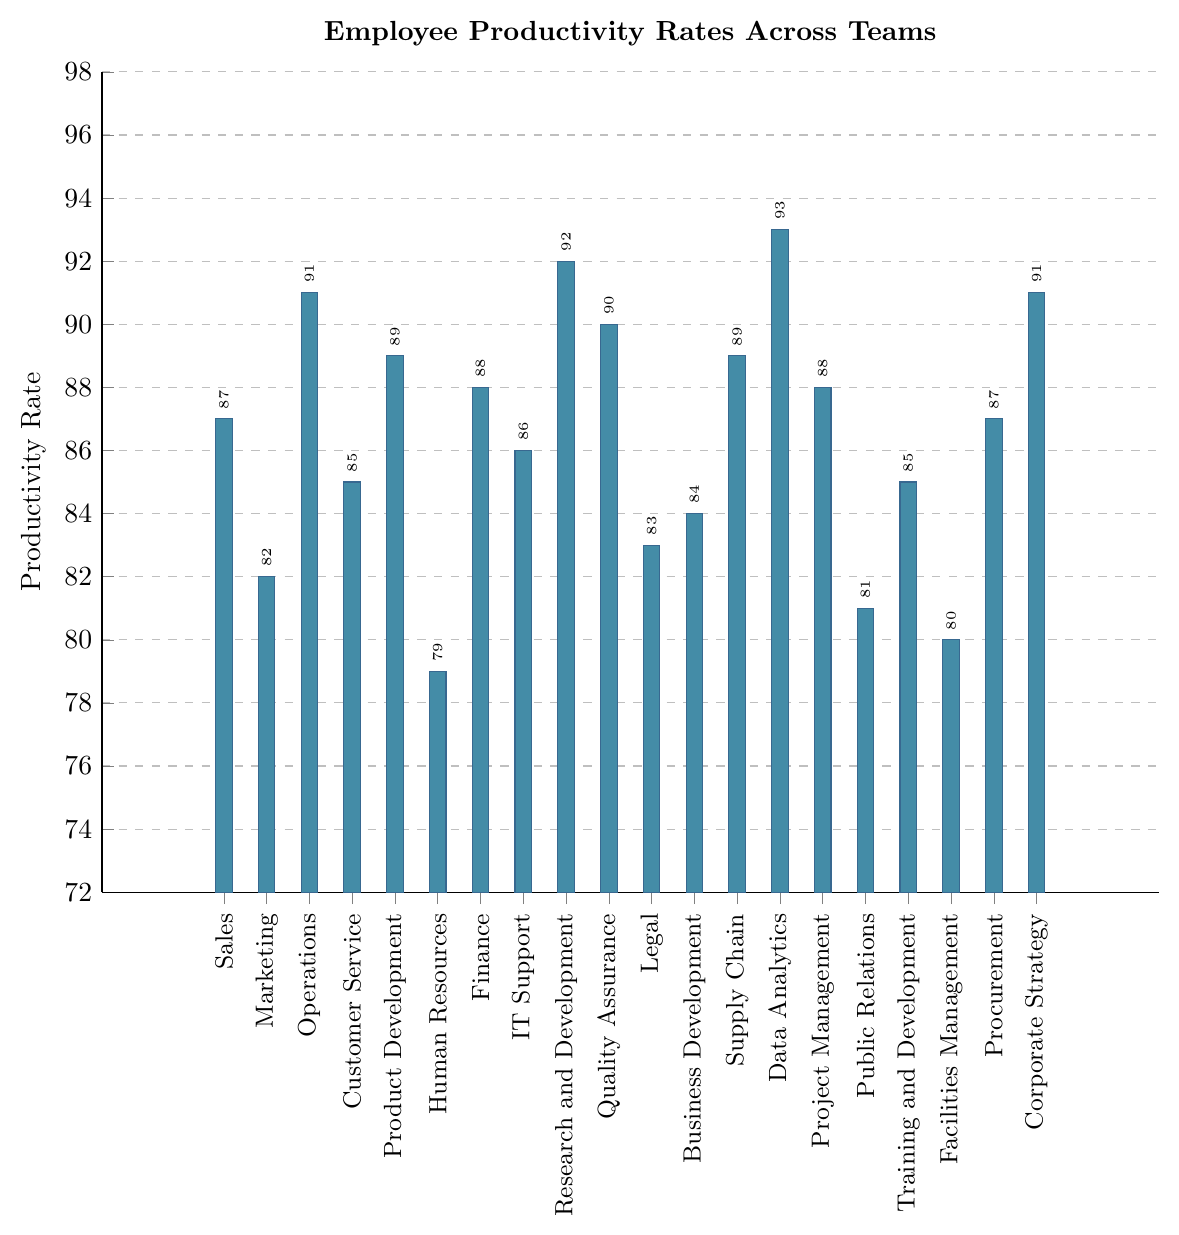Which team has the highest productivity rate? The team with the highest bar in the plot represents the highest productivity rate. The height of the 'Data Analytics' bar is the highest, indicating it has the highest rate.
Answer: Data Analytics Which team has the lowest productivity rate? The team with the lowest bar in the plot represents the lowest productivity rate. The height of the 'Human Resources' bar is the lowest, indicating it has the lowest rate.
Answer: Human Resources How many teams have productivity rates above 90? Identify the bars that surpass the 90 mark on the y-axis. There are four bars higher than 90, specifically those for 'Operations', 'Research and Development', 'Quality Assurance', and 'Data Analytics'.
Answer: 4 What is the difference in productivity rates between the Operations team and the Finance team? Subtract the productivity rate of the Finance team (88) from the productivity rate of the Operations team (91).
Answer: 3 What is the average productivity rate of the teams with productivity rates above 90? First, identify the teams with rates above 90: Operations (91), Research and Development (92), Quality Assurance (90), and Data Analytics (93). The average is calculated as (91 + 92 + 90 + 93) / 4 = 366 / 4.
Answer: 91.5 Which teams have productivity rates exactly equal to 87? Identify the teams whose bars reach up to the 87 mark on the y-axis. The teams are 'Sales' and 'Procurement'.
Answer: Sales, Procurement How does the productivity rate of the Marketing team compare to that of the Legal team? Compare the heights of the bars for 'Marketing' and 'Legal'. The bar for 'Marketing' is lower than that for 'Legal'.
Answer: Marketing is lower What is the range of productivity rates across all teams? Identify the minimum (Human Resources, 79) and maximum (Data Analytics, 93) productivity rates. The range is calculated by subtracting the minimum from the maximum (93 - 79).
Answer: 14 Which teams have productivity rates above the median productivity rate? First, list all productivity rates: 79, 80, 81, 82, 83, 84, 85, 85, 86, 87, 87, 88, 88, 89, 89, 90, 91, 91, 92, 93. The median is the average of the 10th and 11th values (87 + 87) / 2 = 87. Identify teams above this median: Operations, Finance, Research and Development, Quality Assurance, Supply Chain, Data Analytics, Project Management, Corporate Strategy.
Answer: Operations, Finance, Research and Development, Quality Assurance, Supply Chain, Data Analytics, Project Management, Corporate Strategy What is the cumulative productivity rate of all teams in the figure? Add the productivity rates of all 20 teams: (87 + 82 + 91 + 85 + 89 + 79 + 88 + 86 + 92 + 90 + 83 + 84 + 89 + 93 + 88 + 81 + 85 + 80 + 87 + 91). The sum is 1600.
Answer: 1600 